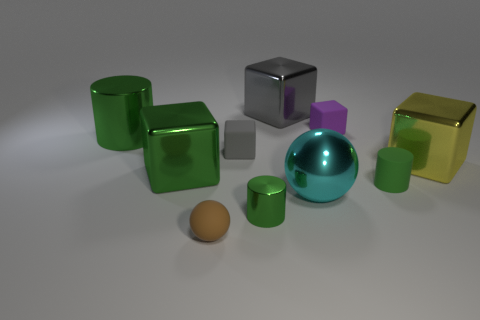Subtract all purple blocks. How many blocks are left? 4 Subtract all green cubes. How many cubes are left? 4 Subtract all brown cubes. Subtract all purple spheres. How many cubes are left? 5 Subtract all balls. How many objects are left? 8 Add 6 big yellow cubes. How many big yellow cubes are left? 7 Add 4 cyan blocks. How many cyan blocks exist? 4 Subtract 0 red blocks. How many objects are left? 10 Subtract all tiny cubes. Subtract all big gray shiny cubes. How many objects are left? 7 